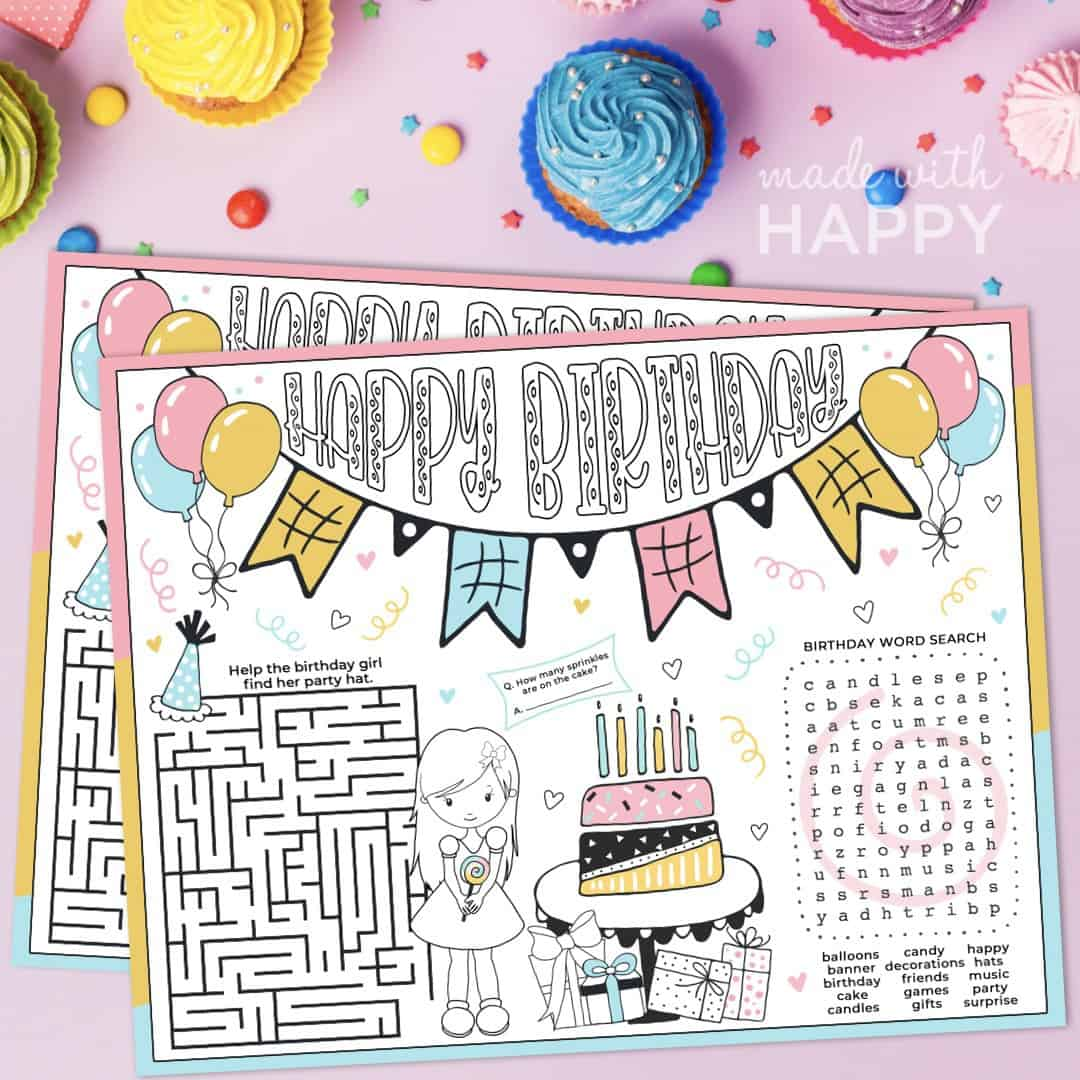Describe the different elements found in the birthday activity sheet. The birthday activity sheet is vibrant and engaging, featuring a maze to help the birthday girl find her party hat, a word search puzzle celebrating birthday-related words, and an image of a birthday cake with questions about the number of sprinkles. It also includes colorful decorations like balloons, presents, and a cheerful 'Happy Birthday' banner. What do you think about the maze? Is it too difficult for children? The maze seems suitable for young children. It is intricate enough to provide a healthy challenge without being overly complex. The design encourages problem-solving and keeps the children engaged, making it perfect for a fun birthday activity. Imagine if the maze could talk. What would it say to the children trying to solve it? The maze might say: 'Welcome, little adventurers! Help our birthday girl find her way to the party hat. Don't rush, take your time and enjoy the journey. Remember, every path has its own special adventure, and I'm here to guide you through the twists and turns. Good luck!' 